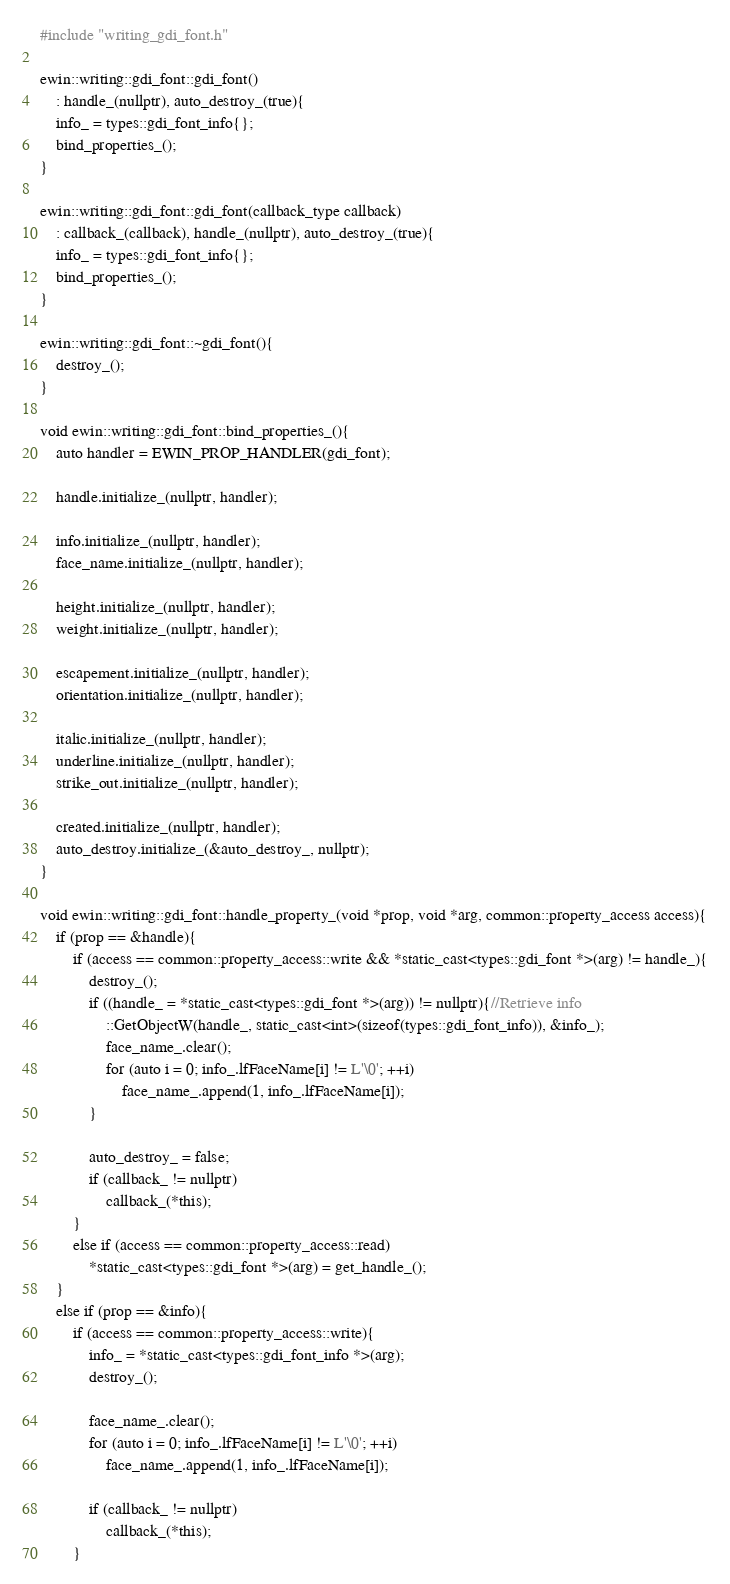<code> <loc_0><loc_0><loc_500><loc_500><_C++_>#include "writing_gdi_font.h"

ewin::writing::gdi_font::gdi_font()
	: handle_(nullptr), auto_destroy_(true){
	info_ = types::gdi_font_info{};
	bind_properties_();
}

ewin::writing::gdi_font::gdi_font(callback_type callback)
	: callback_(callback), handle_(nullptr), auto_destroy_(true){
	info_ = types::gdi_font_info{};
	bind_properties_();
}

ewin::writing::gdi_font::~gdi_font(){
	destroy_();
}

void ewin::writing::gdi_font::bind_properties_(){
	auto handler = EWIN_PROP_HANDLER(gdi_font);

	handle.initialize_(nullptr, handler);

	info.initialize_(nullptr, handler);
	face_name.initialize_(nullptr, handler);

	height.initialize_(nullptr, handler);
	weight.initialize_(nullptr, handler);

	escapement.initialize_(nullptr, handler);
	orientation.initialize_(nullptr, handler);

	italic.initialize_(nullptr, handler);
	underline.initialize_(nullptr, handler);
	strike_out.initialize_(nullptr, handler);

	created.initialize_(nullptr, handler);
	auto_destroy.initialize_(&auto_destroy_, nullptr);
}

void ewin::writing::gdi_font::handle_property_(void *prop, void *arg, common::property_access access){
	if (prop == &handle){
		if (access == common::property_access::write && *static_cast<types::gdi_font *>(arg) != handle_){
			destroy_();
			if ((handle_ = *static_cast<types::gdi_font *>(arg)) != nullptr){//Retrieve info
				::GetObjectW(handle_, static_cast<int>(sizeof(types::gdi_font_info)), &info_);
				face_name_.clear();
				for (auto i = 0; info_.lfFaceName[i] != L'\0'; ++i)
					face_name_.append(1, info_.lfFaceName[i]);
			}

			auto_destroy_ = false;
			if (callback_ != nullptr)
				callback_(*this);
		}
		else if (access == common::property_access::read)
			*static_cast<types::gdi_font *>(arg) = get_handle_();
	}
	else if (prop == &info){
		if (access == common::property_access::write){
			info_ = *static_cast<types::gdi_font_info *>(arg);
			destroy_();

			face_name_.clear();
			for (auto i = 0; info_.lfFaceName[i] != L'\0'; ++i)
				face_name_.append(1, info_.lfFaceName[i]);

			if (callback_ != nullptr)
				callback_(*this);
		}</code> 